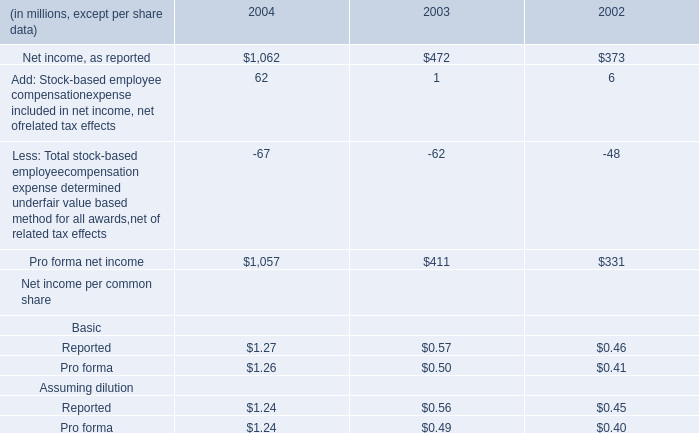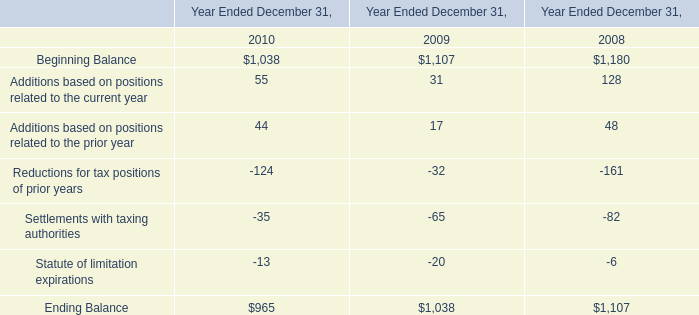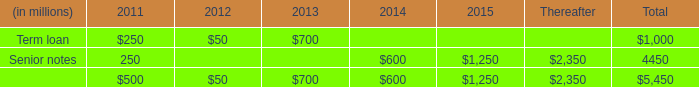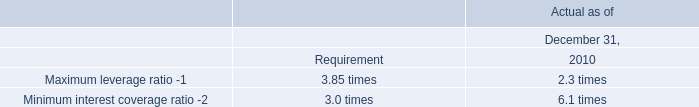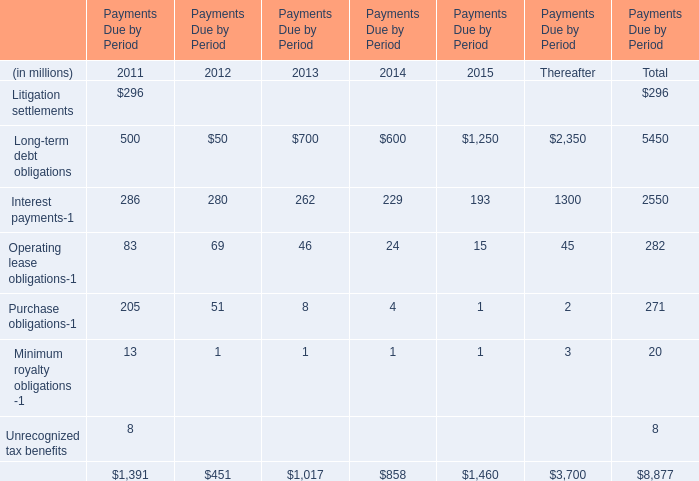What is the percentage of Litigation settlements in relation to the total in 2011? 
Computations: (296 / 1391)
Answer: 0.2128. 